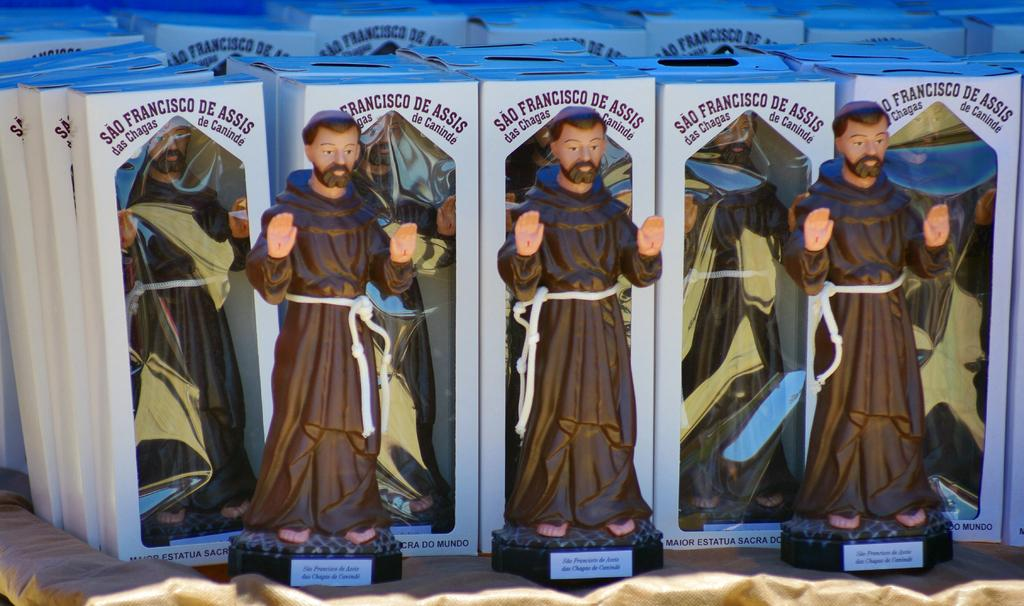What is located towards the bottom of the image? There is a cloth towards the bottom of the image. What type of toys can be seen in the image? There are toys of a man in the image. What is written on the toys? There is text on the toys. What other objects are present in the image? There are boxes in the image. What is written on the boxes? There is text on the boxes. What direction is the representative moving in the image? There is no representative or movement depicted in the image; it only features a cloth, toys of a man, and boxes with text. 